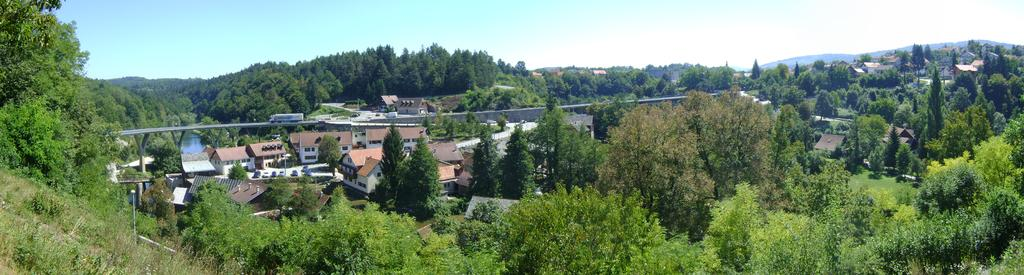What type of vegetation can be seen in the image? There are trees in the image. What color are the trees? The trees are in green color. What structures can be seen in the background of the image? There are buildings in the background of the image. What colors are the buildings? The buildings are in cream and white color. What is visible above the trees and buildings in the image? The sky is visible in the image. What colors can be seen in the sky? The sky is in blue and white color. Can you see any bit or mitten attached to the trees in the image? There are no bits or mittens present on the trees in the image. Are there any creatures with wings visible in the image? There are no creatures with wings visible in the image. 